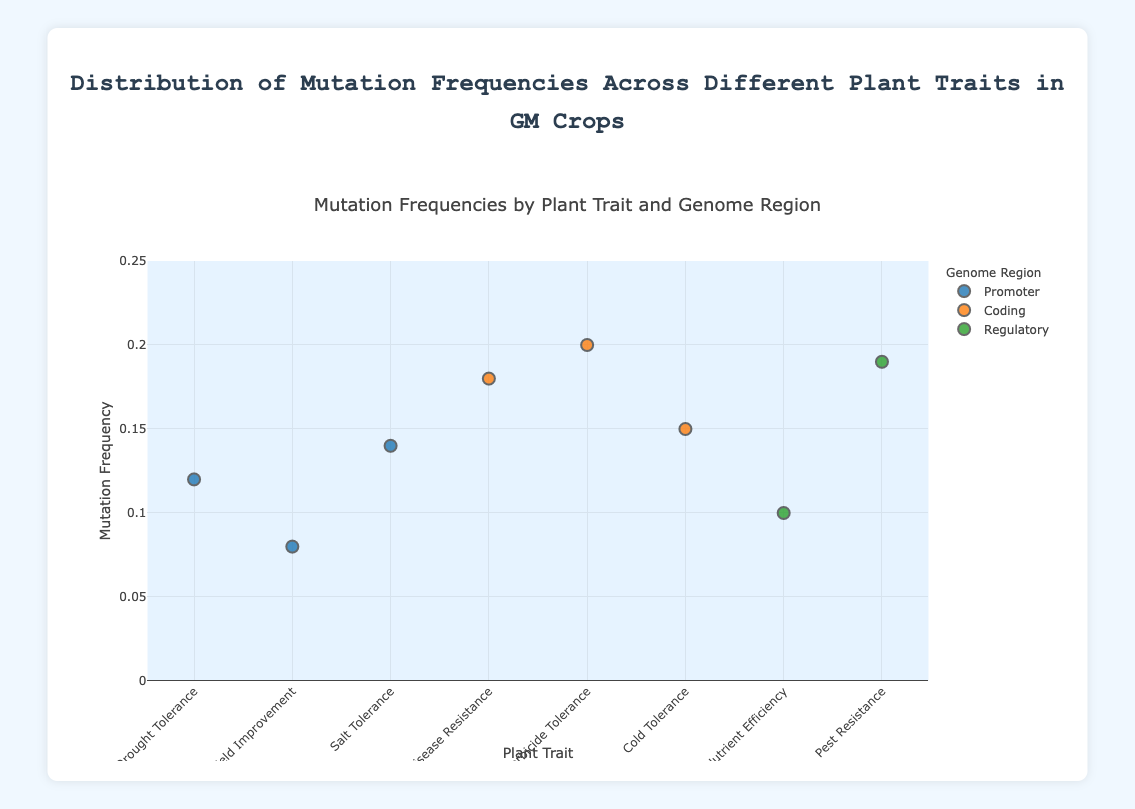What's the title of the figure? The title is displayed at the top of the figure. It reads "Mutation Frequencies by Plant Trait and Genome Region".
Answer: Mutation Frequencies by Plant Trait and Genome Region What are the axis labels? The x-axis label is "Plant Trait" and the y-axis label is "Mutation Frequency". These labels are located along the respective axes.
Answer: Plant Trait (x-axis), Mutation Frequency (y-axis) How many different genome regions are represented in the scatter plot? There are three genome regions represented in the scatter plot: Promoter, Coding, and Regulatory. This is indicated in the legend.
Answer: Three (Promoter, Coding, Regulatory) Which plant trait has the highest mutation frequency? By locating the points on the y-axis, Herbicide Tolerance has the highest mutation frequency at 0.20.
Answer: Herbicide Tolerance What is the mutation frequency for Cold Tolerance? The data point for Cold Tolerance is marked on the y-axis at 0.15.
Answer: 0.15 Which genome region has the highest average mutation frequency? Calculate the average mutation frequency for each genome region. For Promoter: (0.12 + 0.08 + 0.14)/3 = 0.1133. For Coding: (0.18 + 0.20 + 0.15)/3 = 0.1767. For Regulatory: (0.10 + 0.19)/2 = 0.145. Therefore, Coding has the highest average mutation frequency.
Answer: Coding Compare the mutation frequencies between Disease Resistance and Pest Resistance. Which one is higher? Disease Resistance has a mutation frequency of 0.18, whereas Pest Resistance has a frequency of 0.19. Therefore, Pest Resistance has a higher mutation frequency.
Answer: Pest Resistance Which plant traits belong to the Promoter genome region? The traits belonging to the Promoter region are identified by the legend and the scatter plot. They are Drought Tolerance, Yield Improvement, and Salt Tolerance.
Answer: Drought Tolerance, Yield Improvement, Salt Tolerance What is the mutation frequency range for the Regulatory genome region? For the Regulatory region, the Mutation Frequencies are between 0.10 (Nutrient Efficiency) and 0.19 (Pest Resistance).
Answer: 0.10 to 0.19 Is there a plant trait with a mutation frequency below 0.10? Yes, Yield Improvement has a mutation frequency of 0.08. This can be seen from its position on the y-axis.
Answer: Yes, Yield Improvement 